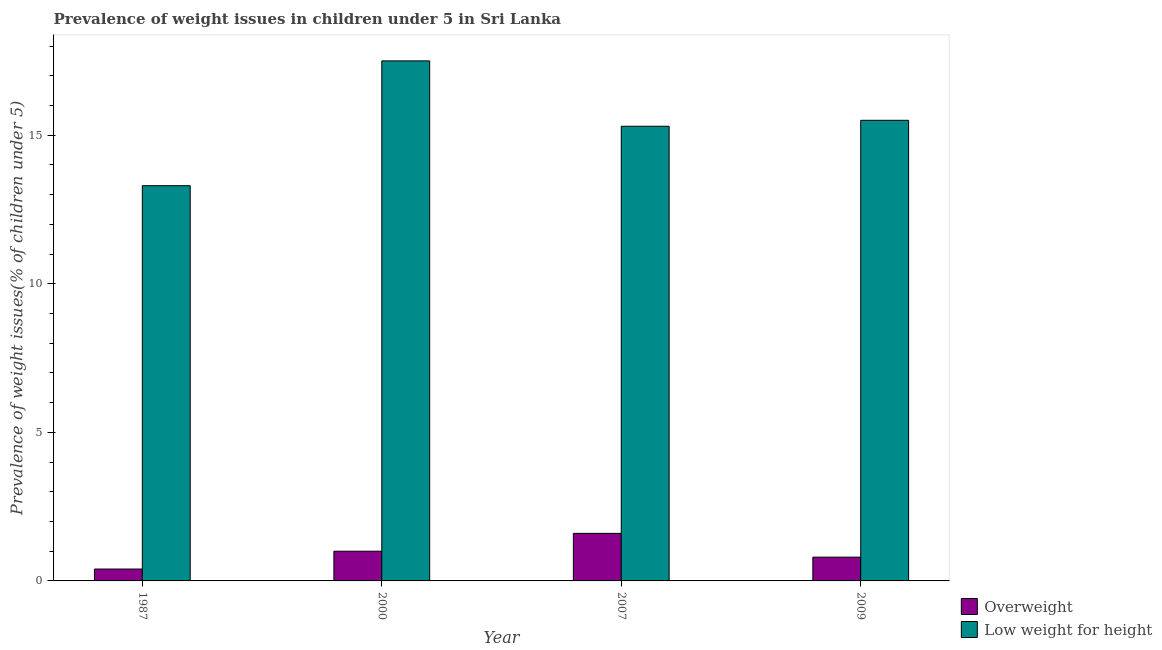Are the number of bars per tick equal to the number of legend labels?
Offer a terse response. Yes. How many bars are there on the 1st tick from the left?
Give a very brief answer. 2. What is the label of the 1st group of bars from the left?
Offer a very short reply. 1987. What is the percentage of underweight children in 2007?
Ensure brevity in your answer.  15.3. Across all years, what is the maximum percentage of overweight children?
Provide a short and direct response. 1.6. Across all years, what is the minimum percentage of overweight children?
Provide a short and direct response. 0.4. In which year was the percentage of underweight children maximum?
Offer a terse response. 2000. In which year was the percentage of overweight children minimum?
Keep it short and to the point. 1987. What is the total percentage of overweight children in the graph?
Provide a short and direct response. 3.8. What is the difference between the percentage of overweight children in 2009 and the percentage of underweight children in 2007?
Keep it short and to the point. -0.8. What is the average percentage of overweight children per year?
Offer a terse response. 0.95. In the year 1987, what is the difference between the percentage of overweight children and percentage of underweight children?
Your answer should be very brief. 0. What is the ratio of the percentage of overweight children in 1987 to that in 2009?
Your response must be concise. 0.5. Is the percentage of overweight children in 2000 less than that in 2009?
Keep it short and to the point. No. What is the difference between the highest and the second highest percentage of underweight children?
Your answer should be very brief. 2. What is the difference between the highest and the lowest percentage of overweight children?
Offer a terse response. 1.2. In how many years, is the percentage of overweight children greater than the average percentage of overweight children taken over all years?
Ensure brevity in your answer.  2. What does the 2nd bar from the left in 2009 represents?
Keep it short and to the point. Low weight for height. What does the 1st bar from the right in 2009 represents?
Give a very brief answer. Low weight for height. How many bars are there?
Give a very brief answer. 8. Are all the bars in the graph horizontal?
Your answer should be very brief. No. Does the graph contain any zero values?
Ensure brevity in your answer.  No. Where does the legend appear in the graph?
Offer a very short reply. Bottom right. How are the legend labels stacked?
Offer a terse response. Vertical. What is the title of the graph?
Your answer should be very brief. Prevalence of weight issues in children under 5 in Sri Lanka. Does "Lower secondary education" appear as one of the legend labels in the graph?
Keep it short and to the point. No. What is the label or title of the Y-axis?
Ensure brevity in your answer.  Prevalence of weight issues(% of children under 5). What is the Prevalence of weight issues(% of children under 5) of Overweight in 1987?
Your response must be concise. 0.4. What is the Prevalence of weight issues(% of children under 5) in Low weight for height in 1987?
Give a very brief answer. 13.3. What is the Prevalence of weight issues(% of children under 5) in Overweight in 2000?
Your response must be concise. 1. What is the Prevalence of weight issues(% of children under 5) in Low weight for height in 2000?
Keep it short and to the point. 17.5. What is the Prevalence of weight issues(% of children under 5) in Overweight in 2007?
Provide a succinct answer. 1.6. What is the Prevalence of weight issues(% of children under 5) in Low weight for height in 2007?
Keep it short and to the point. 15.3. What is the Prevalence of weight issues(% of children under 5) of Overweight in 2009?
Your answer should be very brief. 0.8. Across all years, what is the maximum Prevalence of weight issues(% of children under 5) in Overweight?
Give a very brief answer. 1.6. Across all years, what is the maximum Prevalence of weight issues(% of children under 5) in Low weight for height?
Your answer should be compact. 17.5. Across all years, what is the minimum Prevalence of weight issues(% of children under 5) of Overweight?
Give a very brief answer. 0.4. Across all years, what is the minimum Prevalence of weight issues(% of children under 5) in Low weight for height?
Provide a succinct answer. 13.3. What is the total Prevalence of weight issues(% of children under 5) of Overweight in the graph?
Provide a short and direct response. 3.8. What is the total Prevalence of weight issues(% of children under 5) of Low weight for height in the graph?
Offer a terse response. 61.6. What is the difference between the Prevalence of weight issues(% of children under 5) of Overweight in 1987 and that in 2000?
Provide a short and direct response. -0.6. What is the difference between the Prevalence of weight issues(% of children under 5) in Overweight in 1987 and that in 2009?
Provide a succinct answer. -0.4. What is the difference between the Prevalence of weight issues(% of children under 5) in Low weight for height in 1987 and that in 2009?
Your answer should be compact. -2.2. What is the difference between the Prevalence of weight issues(% of children under 5) of Low weight for height in 2000 and that in 2007?
Make the answer very short. 2.2. What is the difference between the Prevalence of weight issues(% of children under 5) of Overweight in 2000 and that in 2009?
Make the answer very short. 0.2. What is the difference between the Prevalence of weight issues(% of children under 5) in Low weight for height in 2000 and that in 2009?
Your response must be concise. 2. What is the difference between the Prevalence of weight issues(% of children under 5) of Low weight for height in 2007 and that in 2009?
Offer a very short reply. -0.2. What is the difference between the Prevalence of weight issues(% of children under 5) in Overweight in 1987 and the Prevalence of weight issues(% of children under 5) in Low weight for height in 2000?
Give a very brief answer. -17.1. What is the difference between the Prevalence of weight issues(% of children under 5) in Overweight in 1987 and the Prevalence of weight issues(% of children under 5) in Low weight for height in 2007?
Keep it short and to the point. -14.9. What is the difference between the Prevalence of weight issues(% of children under 5) of Overweight in 1987 and the Prevalence of weight issues(% of children under 5) of Low weight for height in 2009?
Provide a succinct answer. -15.1. What is the difference between the Prevalence of weight issues(% of children under 5) in Overweight in 2000 and the Prevalence of weight issues(% of children under 5) in Low weight for height in 2007?
Your answer should be compact. -14.3. What is the difference between the Prevalence of weight issues(% of children under 5) of Overweight in 2000 and the Prevalence of weight issues(% of children under 5) of Low weight for height in 2009?
Provide a succinct answer. -14.5. In the year 1987, what is the difference between the Prevalence of weight issues(% of children under 5) of Overweight and Prevalence of weight issues(% of children under 5) of Low weight for height?
Provide a short and direct response. -12.9. In the year 2000, what is the difference between the Prevalence of weight issues(% of children under 5) of Overweight and Prevalence of weight issues(% of children under 5) of Low weight for height?
Keep it short and to the point. -16.5. In the year 2007, what is the difference between the Prevalence of weight issues(% of children under 5) in Overweight and Prevalence of weight issues(% of children under 5) in Low weight for height?
Keep it short and to the point. -13.7. In the year 2009, what is the difference between the Prevalence of weight issues(% of children under 5) in Overweight and Prevalence of weight issues(% of children under 5) in Low weight for height?
Keep it short and to the point. -14.7. What is the ratio of the Prevalence of weight issues(% of children under 5) of Low weight for height in 1987 to that in 2000?
Give a very brief answer. 0.76. What is the ratio of the Prevalence of weight issues(% of children under 5) in Low weight for height in 1987 to that in 2007?
Give a very brief answer. 0.87. What is the ratio of the Prevalence of weight issues(% of children under 5) of Overweight in 1987 to that in 2009?
Provide a short and direct response. 0.5. What is the ratio of the Prevalence of weight issues(% of children under 5) in Low weight for height in 1987 to that in 2009?
Offer a very short reply. 0.86. What is the ratio of the Prevalence of weight issues(% of children under 5) of Overweight in 2000 to that in 2007?
Provide a succinct answer. 0.62. What is the ratio of the Prevalence of weight issues(% of children under 5) of Low weight for height in 2000 to that in 2007?
Ensure brevity in your answer.  1.14. What is the ratio of the Prevalence of weight issues(% of children under 5) of Overweight in 2000 to that in 2009?
Provide a succinct answer. 1.25. What is the ratio of the Prevalence of weight issues(% of children under 5) of Low weight for height in 2000 to that in 2009?
Your answer should be very brief. 1.13. What is the ratio of the Prevalence of weight issues(% of children under 5) of Low weight for height in 2007 to that in 2009?
Your answer should be compact. 0.99. What is the difference between the highest and the second highest Prevalence of weight issues(% of children under 5) of Low weight for height?
Keep it short and to the point. 2. 